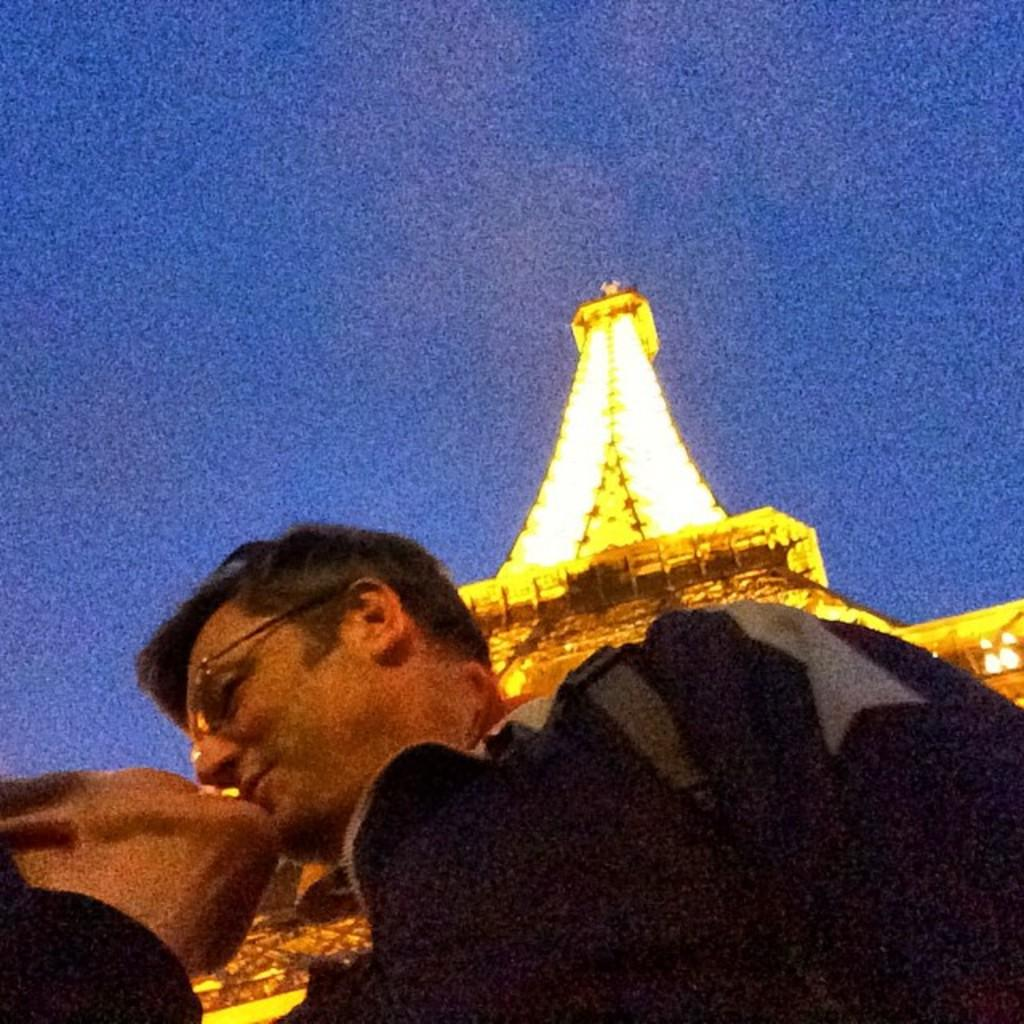How many people are in the image? There are two people in the image. What are the two people doing? The two people are kissing. What can be seen in the background of the image? There is an "Eiffel tower" and the sky visible in the background of the image. What type of war is depicted in the image? There is no war depicted in the image; it features two people kissing in front of the "Eiffel tower." What invention is being used by the ladybug in the image? There is no ladybug present in the image. 